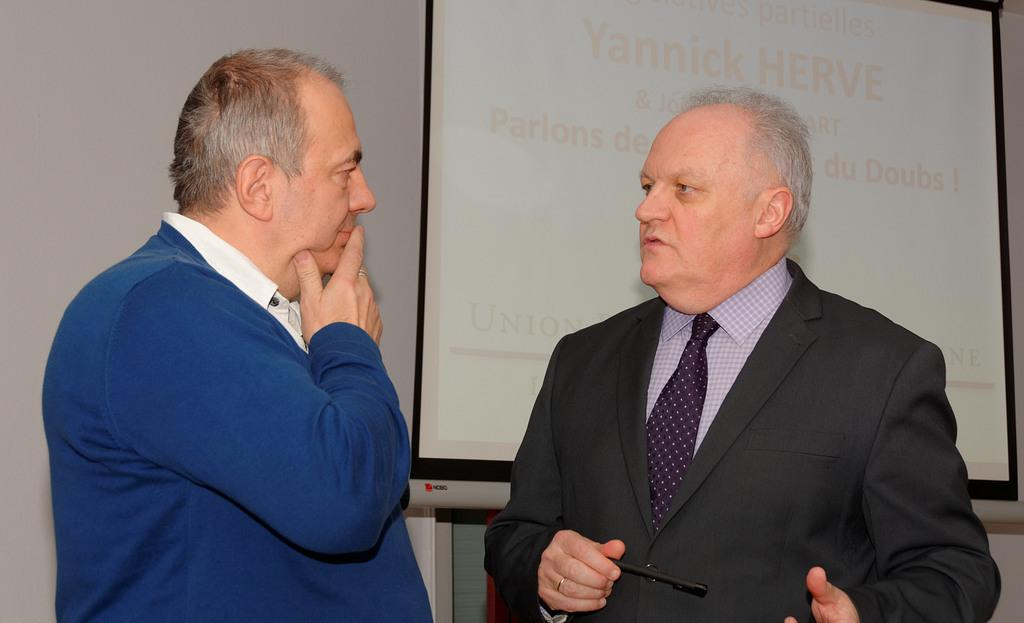How many men are present in the image? There are two men standing in the image. What is the man on the right side wearing? The man on the right side is wearing a blazer. What can be seen in the background of the image? There is a screen in the background of the image. What type of structure is visible in the image? There is a wall visible in the image. How many sponges are being used by the men in the image? There are no sponges present in the image. What type of bikes are the men riding in the image? There are no bikes present in the image. 